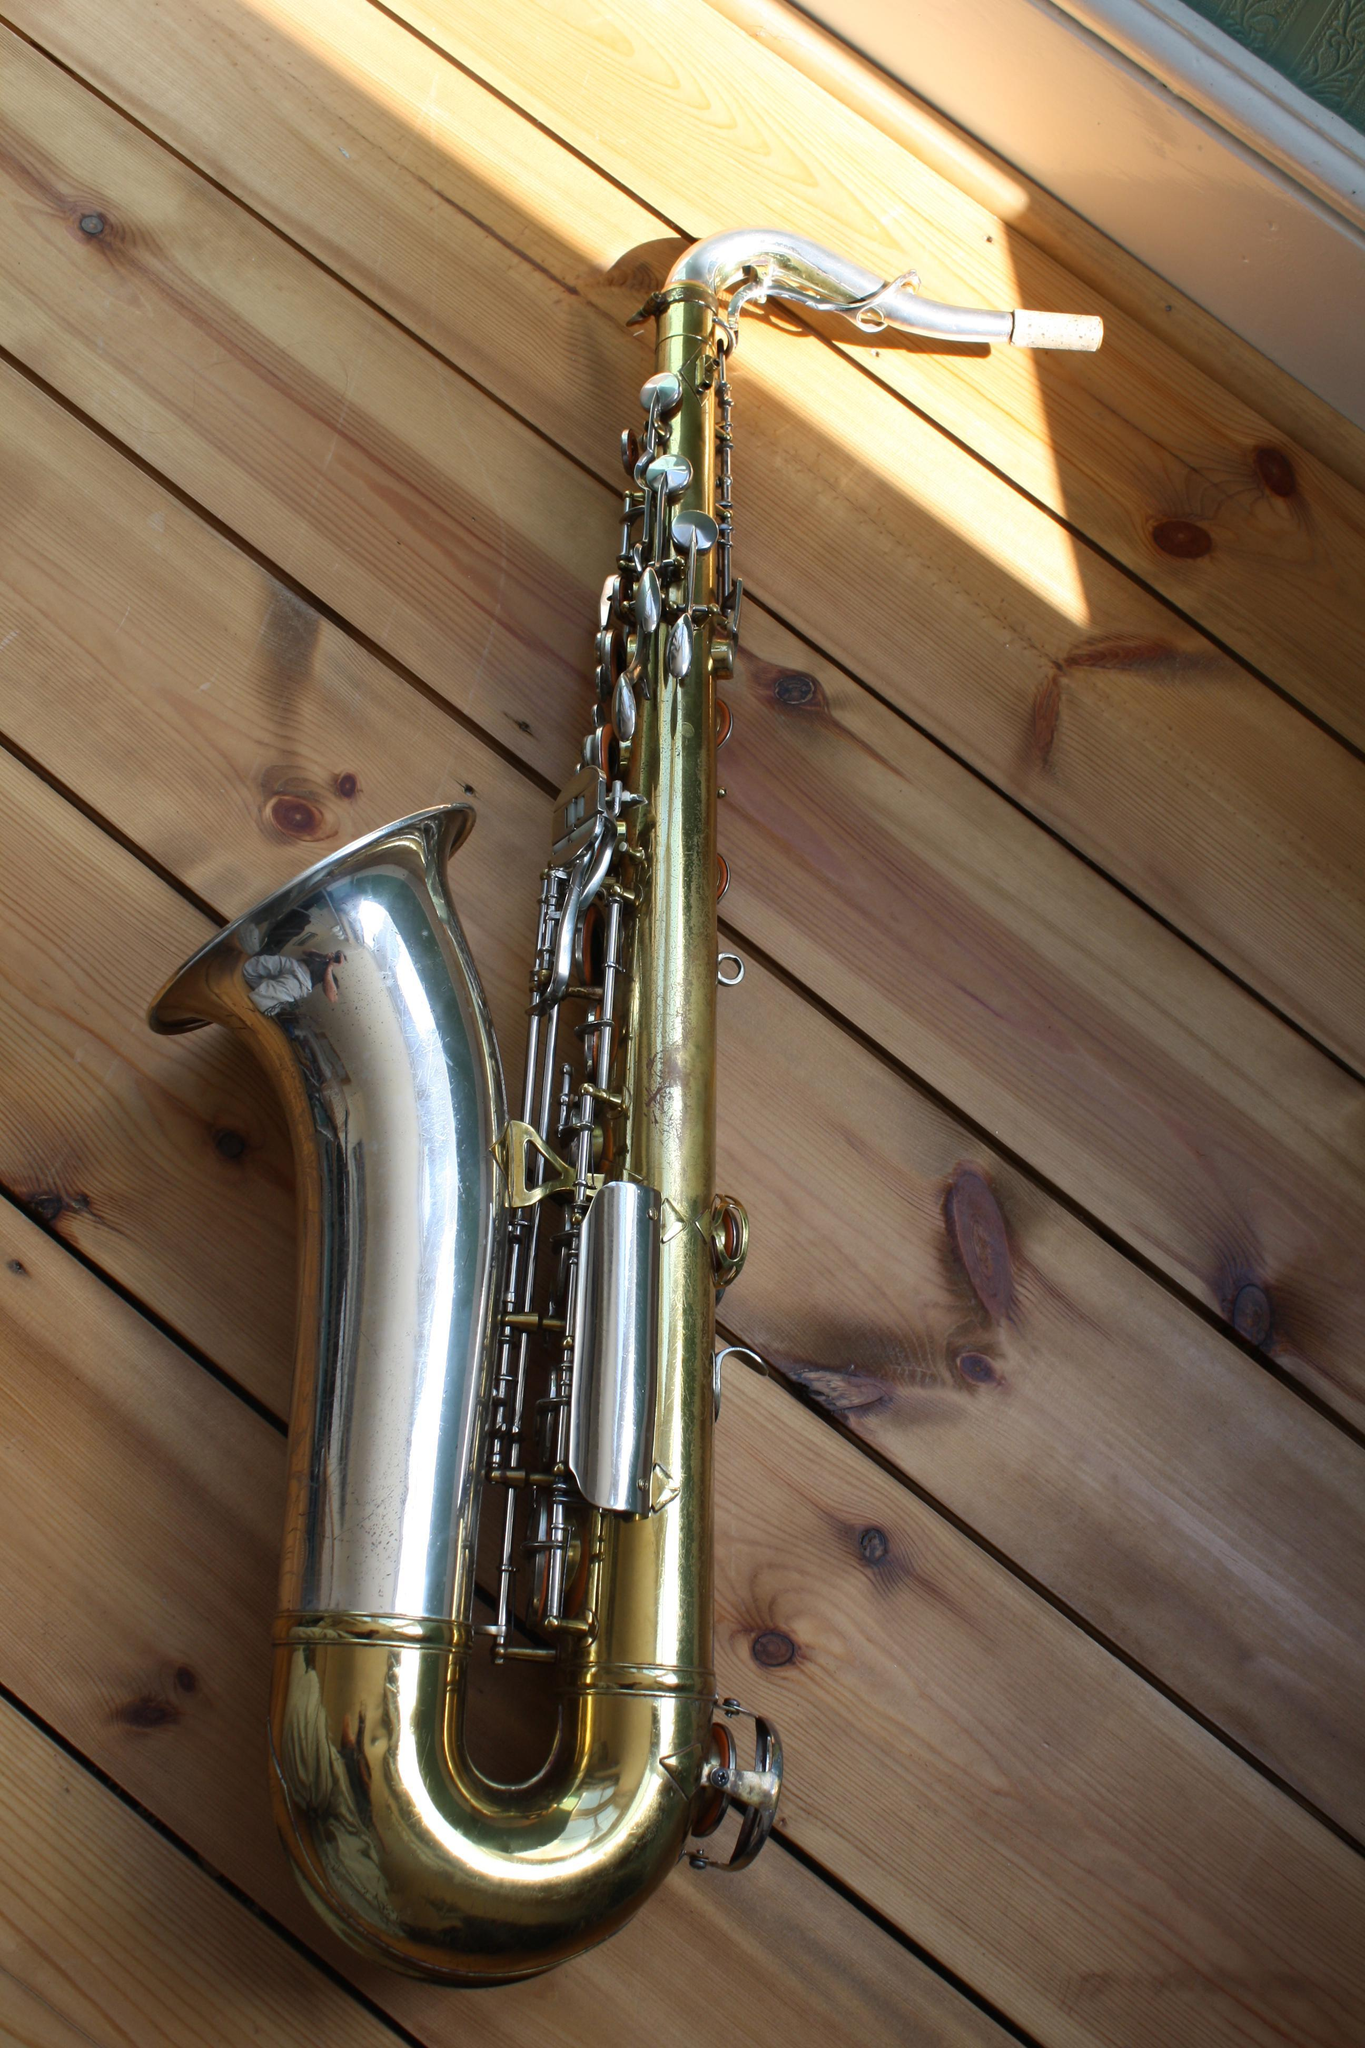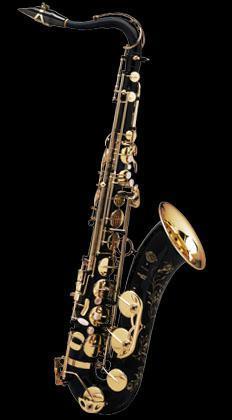The first image is the image on the left, the second image is the image on the right. Examine the images to the left and right. Is the description "At least two intact brass-colored saxophones are displayed with the bell facing rightward." accurate? Answer yes or no. No. 